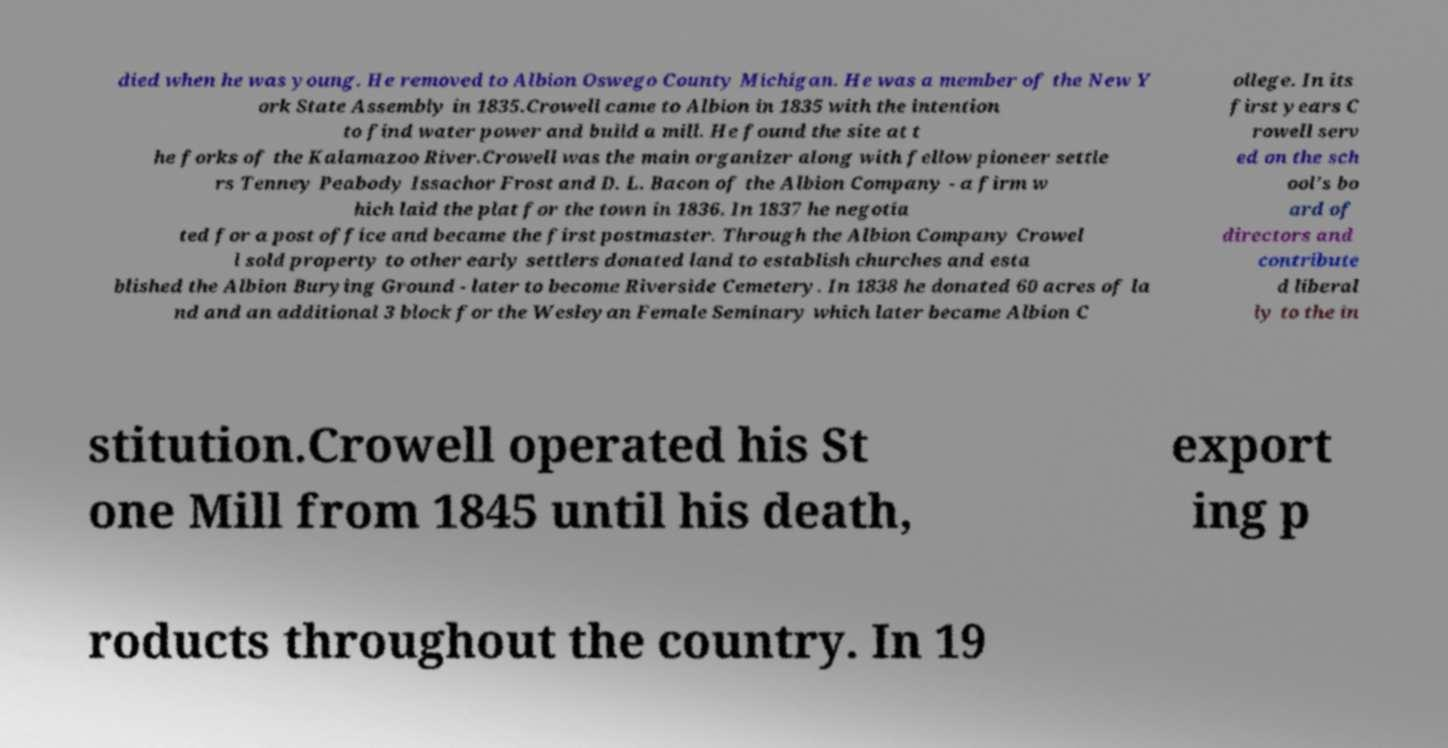There's text embedded in this image that I need extracted. Can you transcribe it verbatim? died when he was young. He removed to Albion Oswego County Michigan. He was a member of the New Y ork State Assembly in 1835.Crowell came to Albion in 1835 with the intention to find water power and build a mill. He found the site at t he forks of the Kalamazoo River.Crowell was the main organizer along with fellow pioneer settle rs Tenney Peabody Issachor Frost and D. L. Bacon of the Albion Company - a firm w hich laid the plat for the town in 1836. In 1837 he negotia ted for a post office and became the first postmaster. Through the Albion Company Crowel l sold property to other early settlers donated land to establish churches and esta blished the Albion Burying Ground - later to become Riverside Cemetery. In 1838 he donated 60 acres of la nd and an additional 3 block for the Wesleyan Female Seminary which later became Albion C ollege. In its first years C rowell serv ed on the sch ool's bo ard of directors and contribute d liberal ly to the in stitution.Crowell operated his St one Mill from 1845 until his death, export ing p roducts throughout the country. In 19 